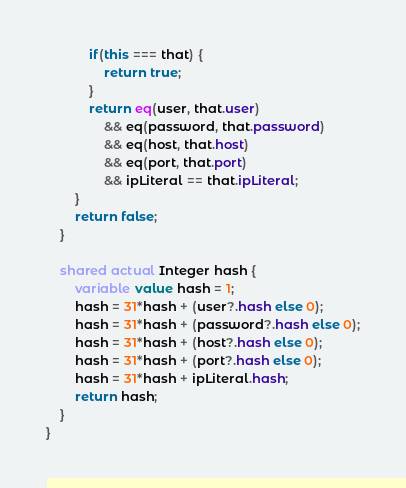Convert code to text. <code><loc_0><loc_0><loc_500><loc_500><_Ceylon_>            if(this === that) {
                return true;
            }
            return eq(user, that.user)
                && eq(password, that.password)
                && eq(host, that.host)
                && eq(port, that.port)
                && ipLiteral == that.ipLiteral;
        }
        return false;
    }
    
    shared actual Integer hash {
        variable value hash = 1;
        hash = 31*hash + (user?.hash else 0);
        hash = 31*hash + (password?.hash else 0);
        hash = 31*hash + (host?.hash else 0);
        hash = 31*hash + (port?.hash else 0);
        hash = 31*hash + ipLiteral.hash;
        return hash;
    }
}
</code> 